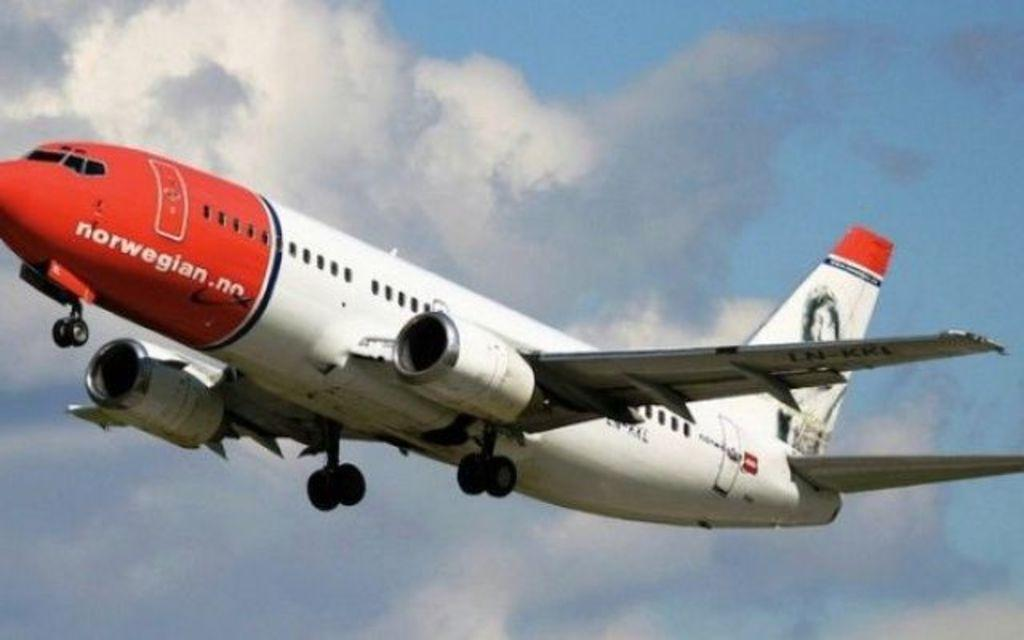<image>
Relay a brief, clear account of the picture shown. An ascending aircraft belongs to the Norwegian Air Shuttle company. 